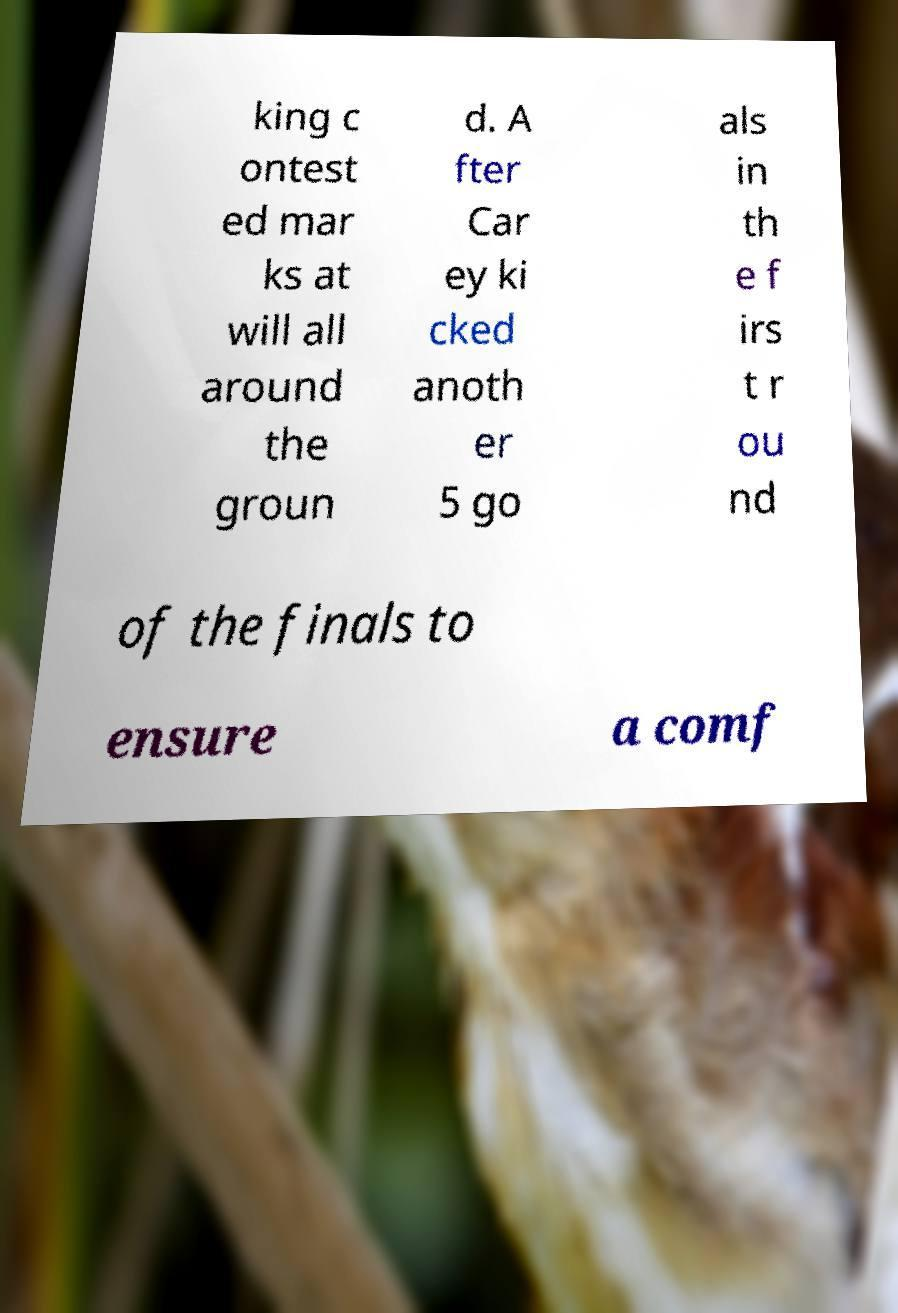Please read and relay the text visible in this image. What does it say? king c ontest ed mar ks at will all around the groun d. A fter Car ey ki cked anoth er 5 go als in th e f irs t r ou nd of the finals to ensure a comf 